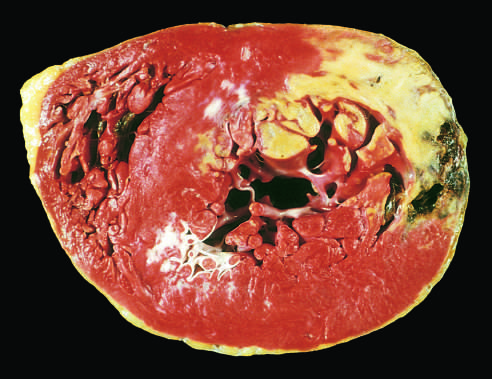what is due to enzyme leakage after cell death?
Answer the question using a single word or phrase. The absence of staining 